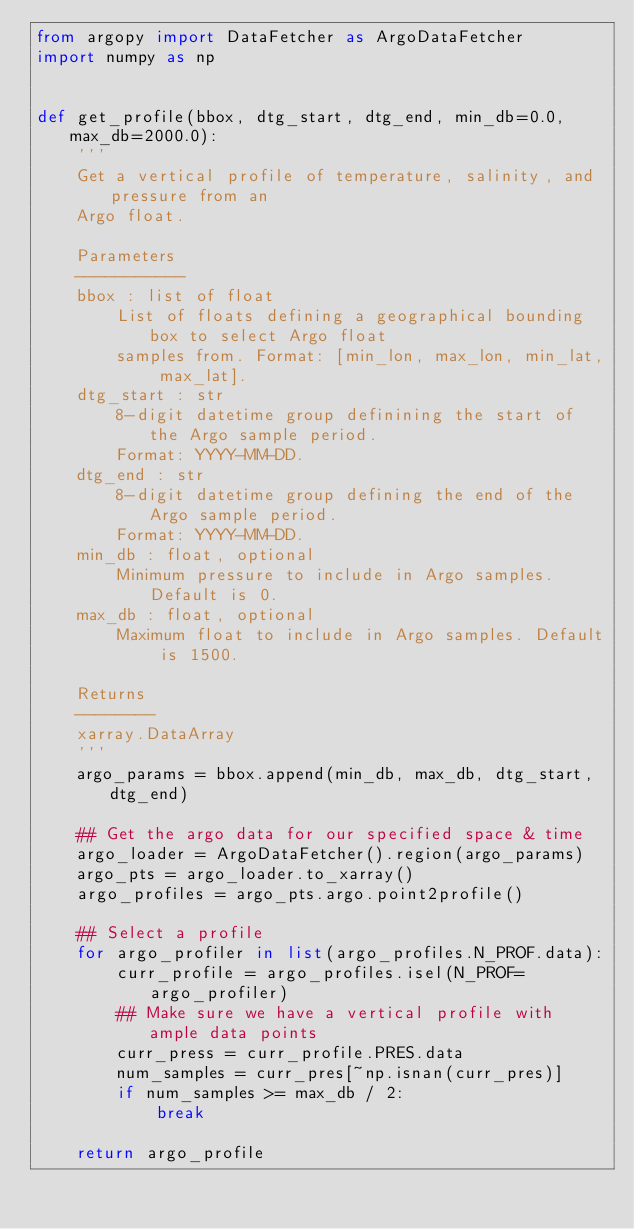Convert code to text. <code><loc_0><loc_0><loc_500><loc_500><_Python_>from argopy import DataFetcher as ArgoDataFetcher
import numpy as np


def get_profile(bbox, dtg_start, dtg_end, min_db=0.0, max_db=2000.0):
    '''
    Get a vertical profile of temperature, salinity, and pressure from an
    Argo float.

    Parameters
    -----------
    bbox : list of float
        List of floats defining a geographical bounding box to select Argo float
        samples from. Format: [min_lon, max_lon, min_lat, max_lat].
    dtg_start : str
        8-digit datetime group definining the start of the Argo sample period.
        Format: YYYY-MM-DD.
    dtg_end : str
        8-digit datetime group defining the end of the Argo sample period.
        Format: YYYY-MM-DD.
    min_db : float, optional
        Minimum pressure to include in Argo samples. Default is 0.
    max_db : float, optional
        Maximum float to include in Argo samples. Default is 1500.

    Returns
    --------
    xarray.DataArray
    '''
    argo_params = bbox.append(min_db, max_db, dtg_start, dtg_end)

    ## Get the argo data for our specified space & time
    argo_loader = ArgoDataFetcher().region(argo_params)
    argo_pts = argo_loader.to_xarray()
    argo_profiles = argo_pts.argo.point2profile()

    ## Select a profile
    for argo_profiler in list(argo_profiles.N_PROF.data):
        curr_profile = argo_profiles.isel(N_PROF=argo_profiler)
        ## Make sure we have a vertical profile with ample data points
        curr_press = curr_profile.PRES.data
        num_samples = curr_pres[~np.isnan(curr_pres)]
        if num_samples >= max_db / 2:
            break

    return argo_profile
</code> 